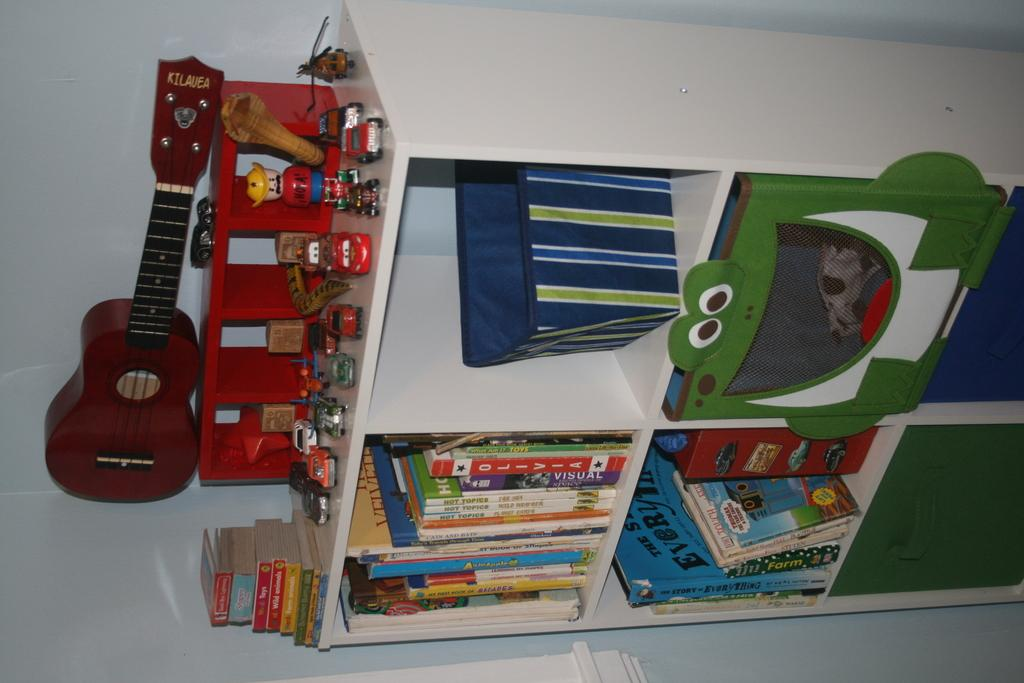Where was the image taken? The image was taken in a room. What furniture is present in the room? There is a cupboard and racks in the room. What items can be found on the racks? Books are kept on the racks. What other items are visible in the room? Cars, a guitar, and books are at the top of the room. What can be seen in the background of the room? There is a wall in the background of the room. What channel is the band playing on in the image? There is no band or channel present in the image; it is a room with various items and furniture. 